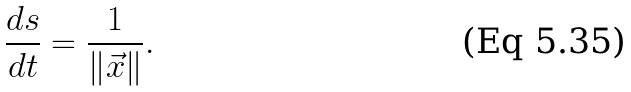<formula> <loc_0><loc_0><loc_500><loc_500>\frac { d s } { d t } = \frac { 1 } { \left \| \vec { x } \right \| } .</formula> 